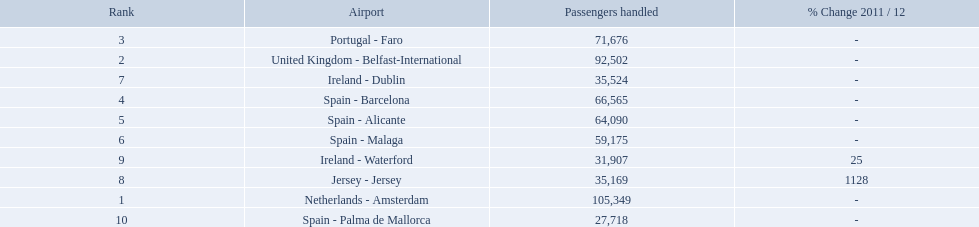What are all the passengers handled values for london southend airport? 105,349, 92,502, 71,676, 66,565, 64,090, 59,175, 35,524, 35,169, 31,907, 27,718. Which are 30,000 or less? 27,718. What airport is this for? Spain - Palma de Mallorca. 